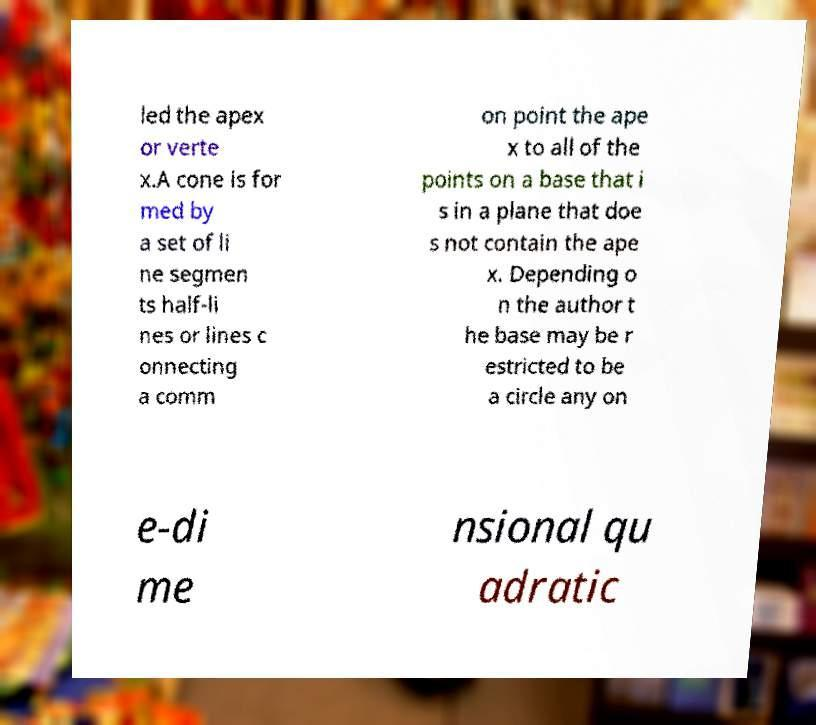I need the written content from this picture converted into text. Can you do that? led the apex or verte x.A cone is for med by a set of li ne segmen ts half-li nes or lines c onnecting a comm on point the ape x to all of the points on a base that i s in a plane that doe s not contain the ape x. Depending o n the author t he base may be r estricted to be a circle any on e-di me nsional qu adratic 